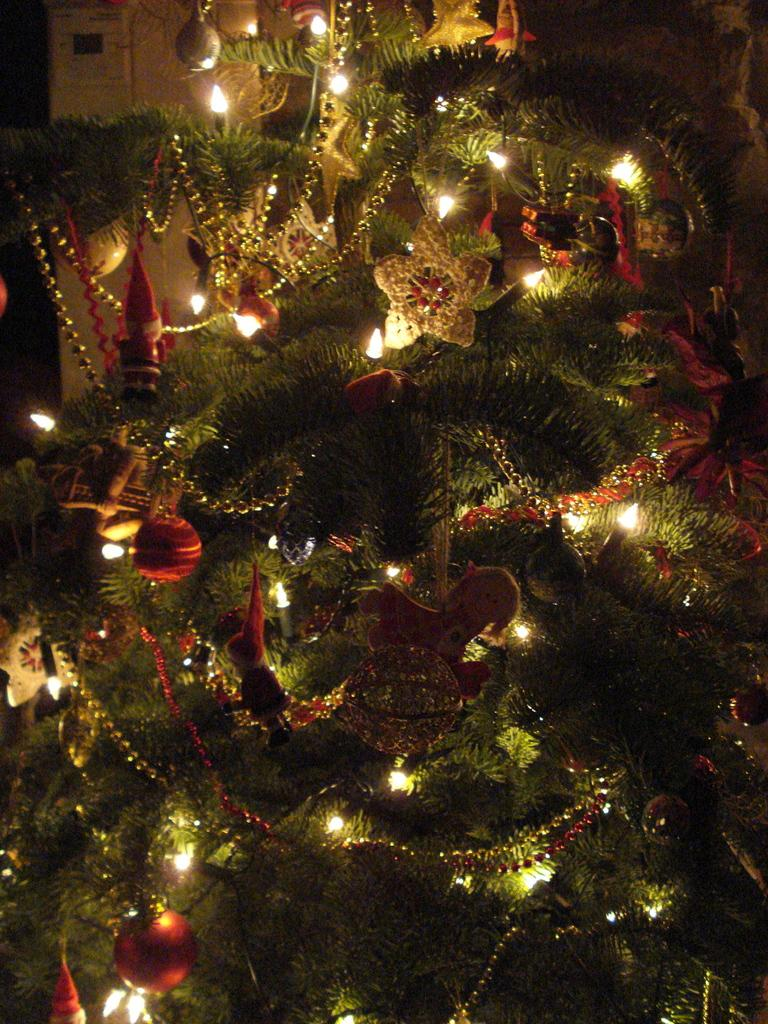What type of tree is in the image? There is a Christmas tree in the image. How is the Christmas tree decorated? The Christmas tree is decorated with lights, balls, chains, and dolls. What verse is written on the sheet of paper hanging from the Christmas tree? There is no sheet of paper or any verse mentioned in the image. The image only shows a Christmas tree decorated with lights, balls, chains, and dolls. 